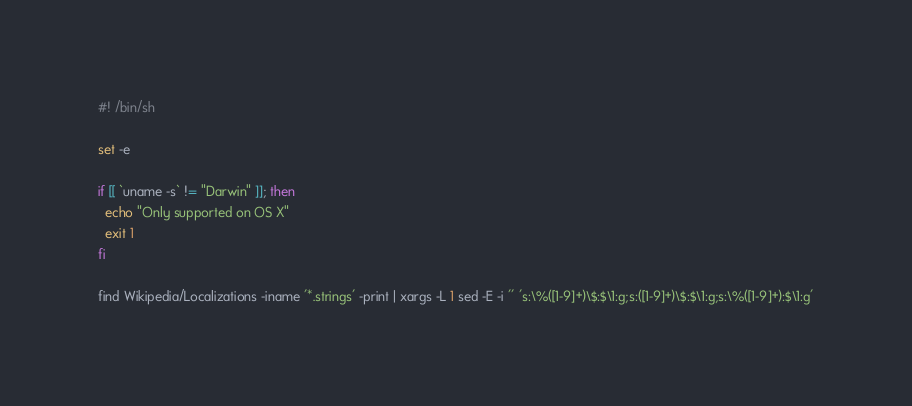Convert code to text. <code><loc_0><loc_0><loc_500><loc_500><_Bash_>#! /bin/sh

set -e

if [[ `uname -s` != "Darwin" ]]; then
  echo "Only supported on OS X"
  exit 1
fi

find Wikipedia/Localizations -iname '*.strings' -print | xargs -L 1 sed -E -i '' 's:\%([1-9]+)\$:$\1:g;s:([1-9]+)\$:$\1:g;s:\%([1-9]+):$\1:g'</code> 